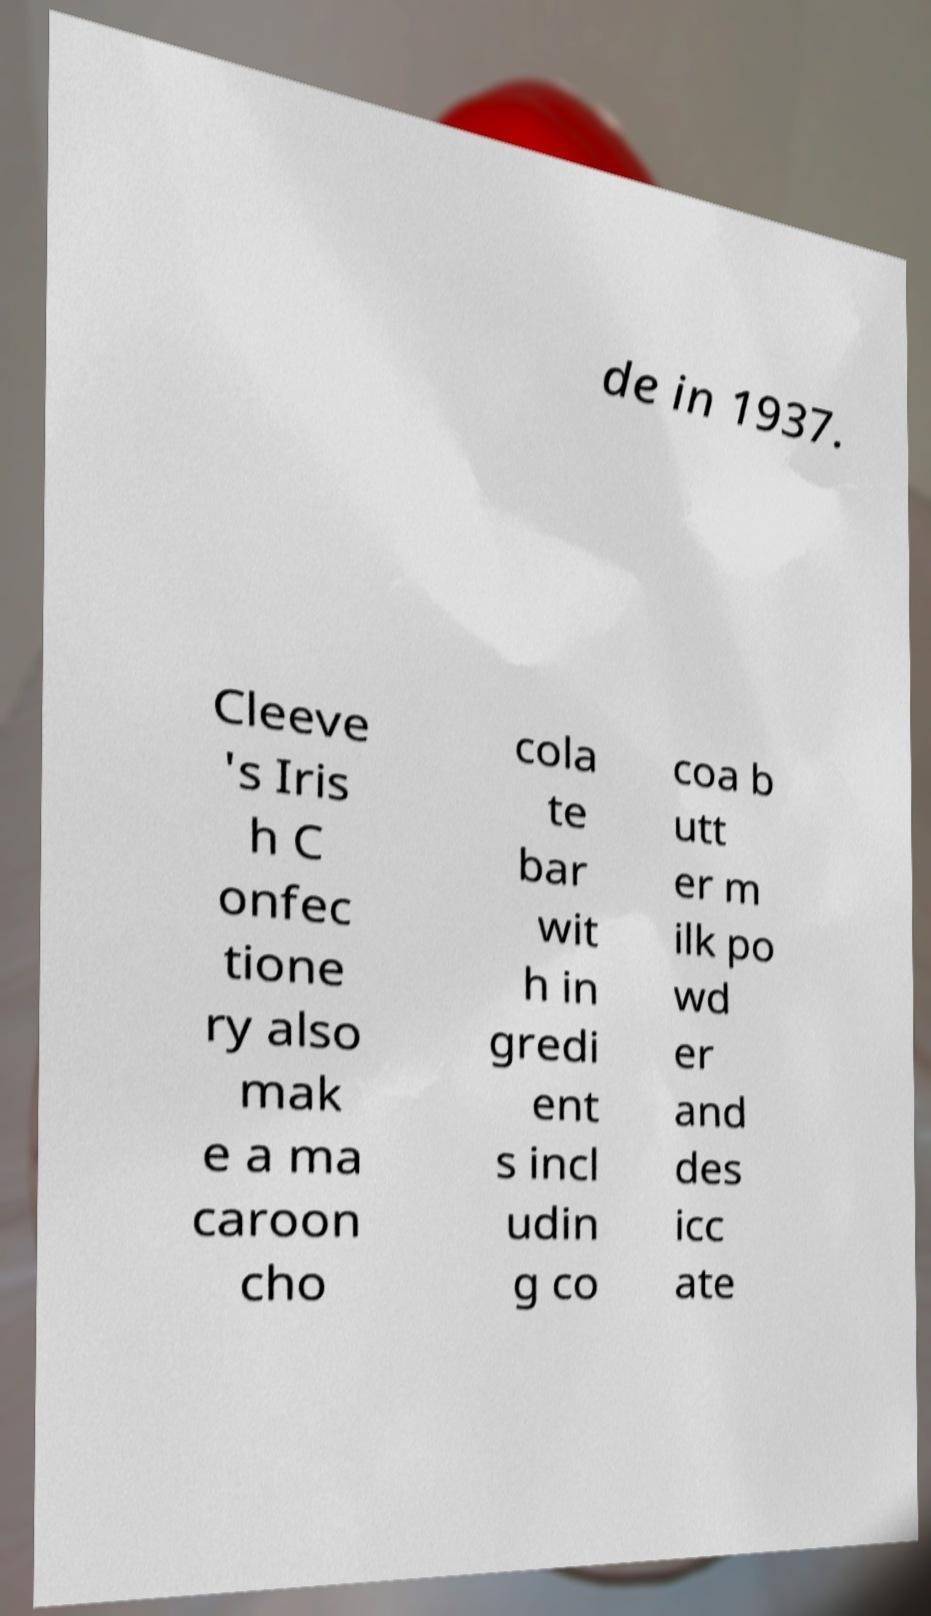For documentation purposes, I need the text within this image transcribed. Could you provide that? de in 1937. Cleeve 's Iris h C onfec tione ry also mak e a ma caroon cho cola te bar wit h in gredi ent s incl udin g co coa b utt er m ilk po wd er and des icc ate 